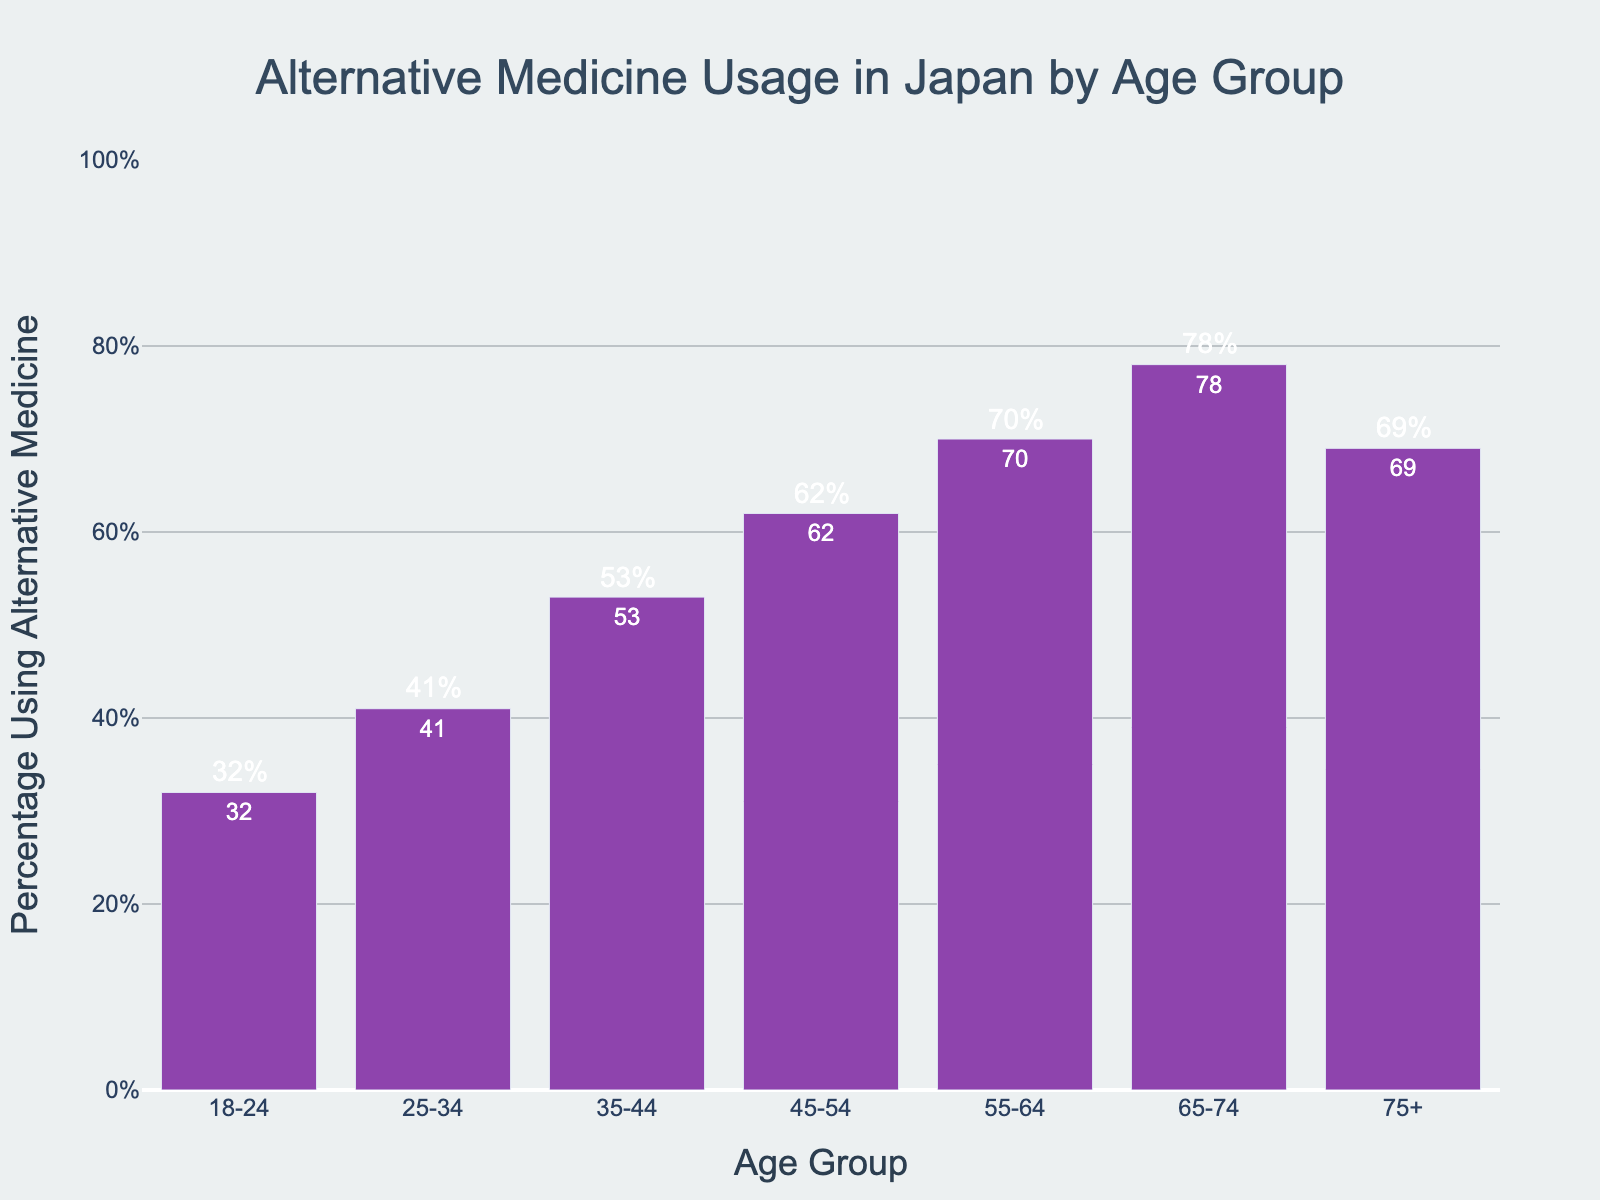Which age group uses alternative medicine the most? The age group 65-74 has the highest percentage of people using alternative medicine, at 78%.
Answer: 65-74 Which age group has the lowest usage of alternative medicine? The age group 18-24 has the lowest usage of alternative medicine, with 32%.
Answer: 18-24 What is the difference in the percentage using alternative medicine between the age groups 25-34 and 55-64? The percentage for the 25-34 age group is 41%, and for the 55-64 age group, it is 70%. The difference is 70% - 41% = 29%.
Answer: 29% Calculate the average percentage of alternative medicine usage for age groups 35-44 and 45-54 combined. The percentage for the 35-44 age group is 53% and for the 45-54 age group, it is 62%. The average is (53% + 62%) / 2 = 57.5%.
Answer: 57.5% Which age group has a percentage usage closest to 50%? The age group 35-44 has a percentage usage of 53%, which is closest to 50%.
Answer: 35-44 By how much did the percentage of alternative medicine usage increase between the age groups 18-24 and 35-44? The percentage for the 18-24 age group is 32%, and for the 35-44 age group, it is 53%. The increase is 53% - 32% = 21%.
Answer: 21% Which age groups show a decline in the usage of alternative medicine in older age demographics? The age groups 65-74 show the highest usage at 78%, and the 75+ group shows a decline to 69%.
Answer: 75+ What is the sum of the percentages of alternative medicine usage for all age groups below 45 years old? The percentages are 32% for 18-24, 41% for 25-34, and 53% for 35-44. The sum is 32% + 41% + 53% = 126%.
Answer: 126% Which age group has the second-highest rate of alternative medicine usage? The age group 75+ has the second-highest rate of alternative medicine usage at 69%.
Answer: 75+ What is the percentage usage difference between the highest and lowest age groups? The highest is 78% (65-74) and the lowest is 32% (18-24), the difference is 78% - 32% = 46%.
Answer: 46% 